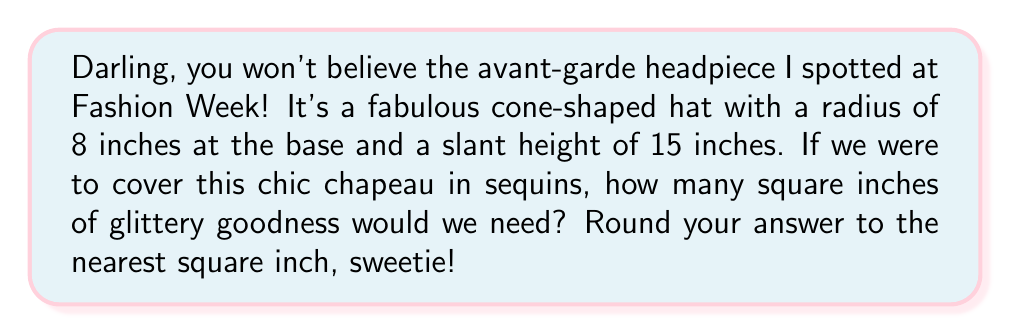Can you answer this question? Alright, let's break this down step-by-step, like we're dissecting the latest runway trends:

1) The surface area of a cone consists of two parts: the circular base and the lateral surface (the part that wraps around).

2) For the circular base, we use the formula for the area of a circle:
   $$A_{base} = \pi r^2$$
   where $r$ is the radius of the base.

3) For the lateral surface, we use the formula:
   $$A_{lateral} = \pi r s$$
   where $r$ is the radius of the base and $s$ is the slant height.

4) The total surface area is the sum of these two:
   $$A_{total} = A_{base} + A_{lateral} = \pi r^2 + \pi r s$$

5) Let's plug in our values:
   $r = 8$ inches (radius of the base)
   $s = 15$ inches (slant height)

6) Now, let's calculate:
   $$A_{total} = \pi (8^2) + \pi (8 \cdot 15)$$
   $$= 64\pi + 120\pi$$
   $$= 184\pi$$

7) Using $\pi \approx 3.14159$, we get:
   $$A_{total} \approx 184 \cdot 3.14159 \approx 578.05$$

8) Rounding to the nearest square inch:
   $$A_{total} \approx 578 \text{ square inches}$$

[asy]
import geometry;

size(200);

real r = 8;
real h = sqrt(15^2 - r^2);

pair O = (0,0);
pair A = (r,0);
pair B = (-r,0);
pair C = (0,h);

draw(O--A--C--O);
draw(O--B,dashed);
draw(arc(O,A,180),dashed);

label("8", (r/2,-0.5));
label("15", (r/2+0.5,h/2), E);

dot("O", O, SW);
dot("A", A, SE);
dot("C", C, N);
[/asy]
Answer: 578 square inches 